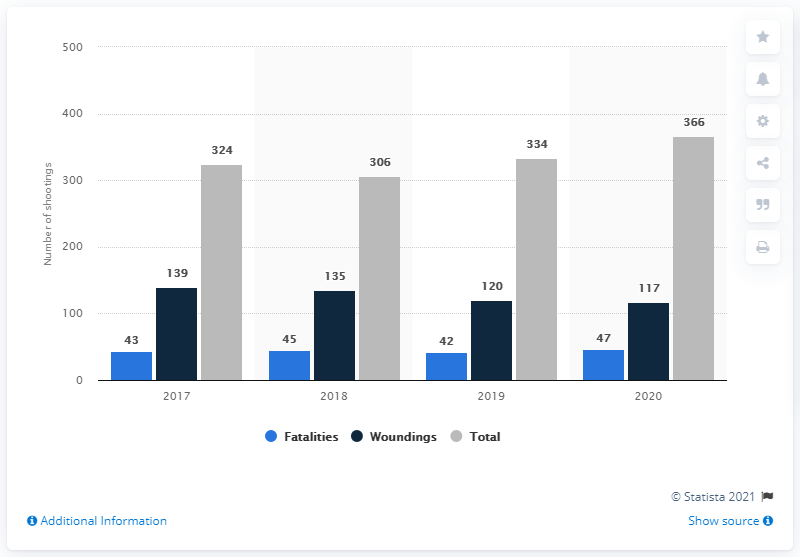Identify some key points in this picture. In 2020, 47 people were killed in shootings in Sweden. According to reports, 117 individuals survived the shootings in Sweden. There were 366 shootings in Sweden in 2020. 